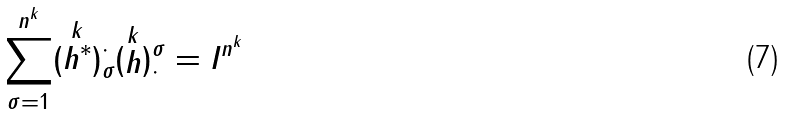<formula> <loc_0><loc_0><loc_500><loc_500>\sum _ { \sigma = 1 } ^ { n ^ { k } } ( \stackrel { k } { h ^ { * } } ) ^ { \cdot } _ { \sigma } ( \stackrel { k } { h } ) ^ { \sigma } _ { \cdot } = I ^ { n ^ { k } }</formula> 